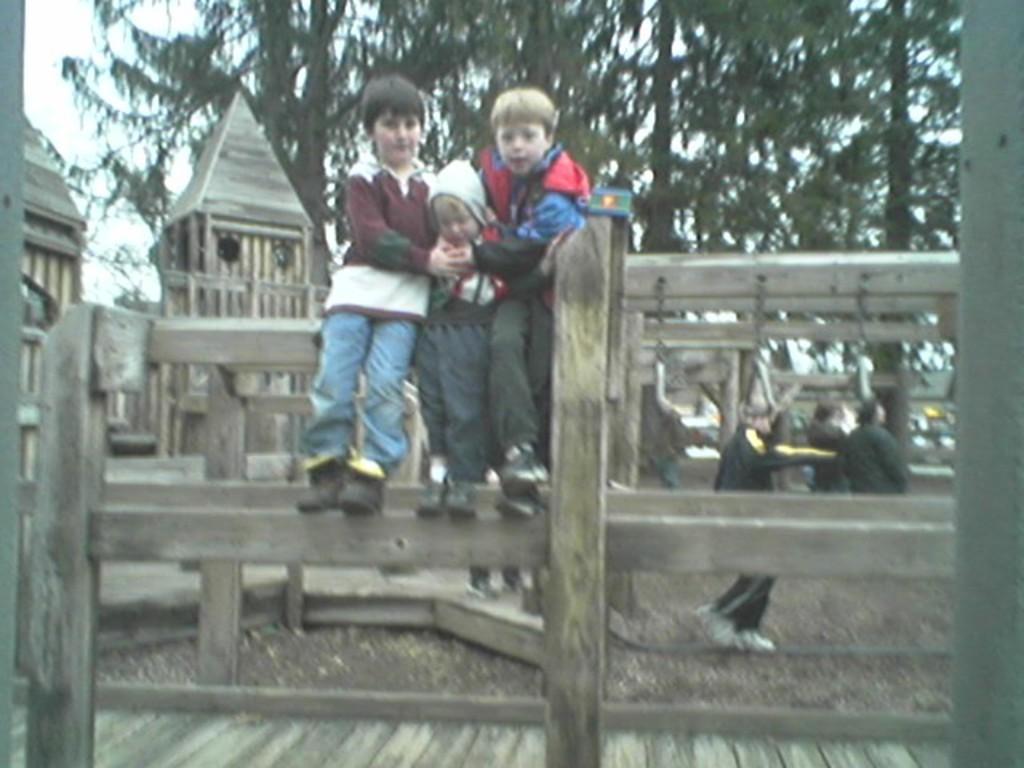How many kids are standing on the wooden fence in the image? There are three kids standing on the wooden fence in the image. What else can be seen in the image besides the kids on the fence? There is a group of people and wooden houses in the image. What is visible in the background of the image? Trees and the sky are visible in the background of the image. What type of toy can be seen in the hands of the kids in the image? There is no toy visible in the hands of the kids in the image. Is there a church present in the image? There is no church present in the image. 